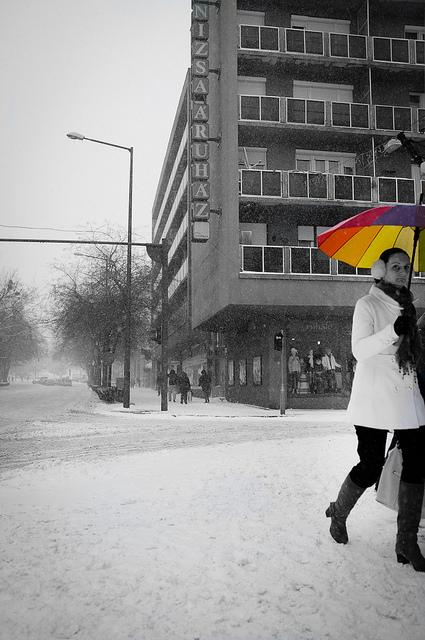Is it snowing?
Give a very brief answer. Yes. What is the only object in color?
Keep it brief. Umbrella. Is the snow melting?
Answer briefly. No. Why is this female wearing a sweater and carry umbrella with her?
Quick response, please. Snowing. 